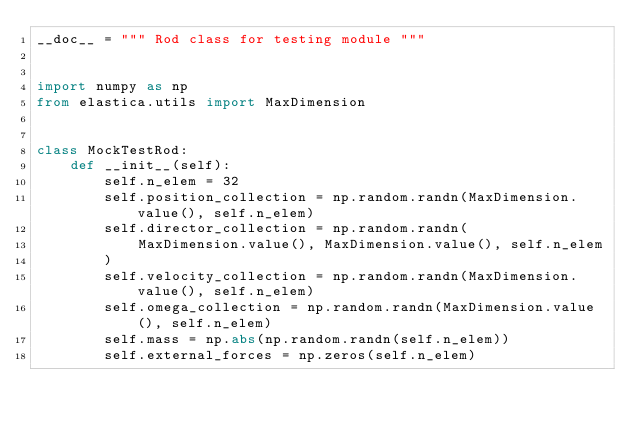<code> <loc_0><loc_0><loc_500><loc_500><_Python_>__doc__ = """ Rod class for testing module """


import numpy as np
from elastica.utils import MaxDimension


class MockTestRod:
    def __init__(self):
        self.n_elem = 32
        self.position_collection = np.random.randn(MaxDimension.value(), self.n_elem)
        self.director_collection = np.random.randn(
            MaxDimension.value(), MaxDimension.value(), self.n_elem
        )
        self.velocity_collection = np.random.randn(MaxDimension.value(), self.n_elem)
        self.omega_collection = np.random.randn(MaxDimension.value(), self.n_elem)
        self.mass = np.abs(np.random.randn(self.n_elem))
        self.external_forces = np.zeros(self.n_elem)
</code> 